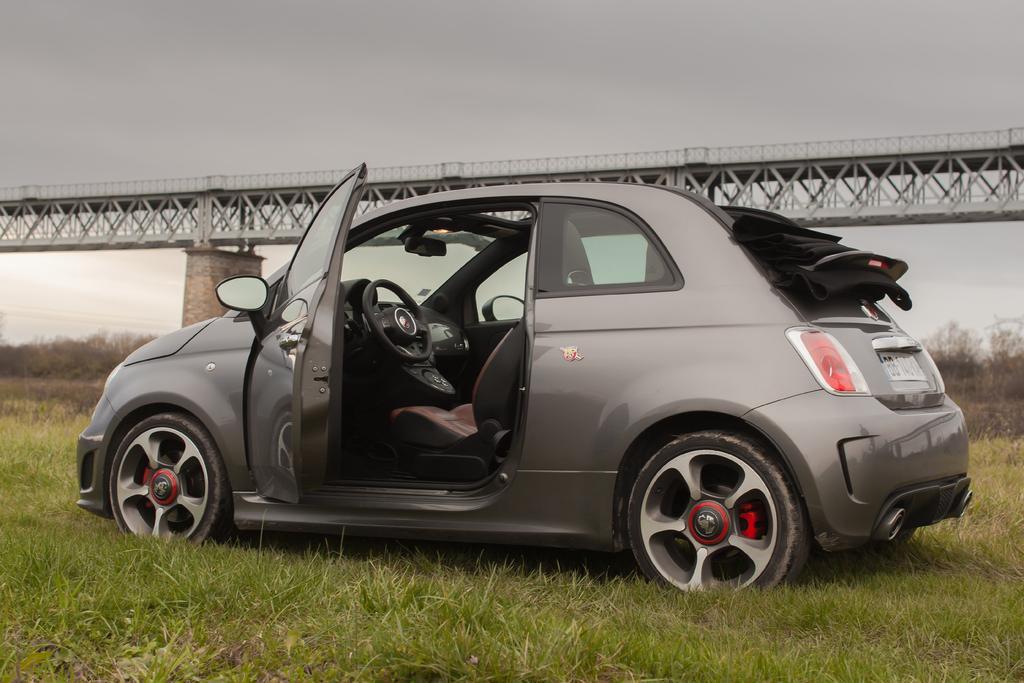Could you give a brief overview of what you see in this image? In this image we can see a motor vehicle on the grass, bridge with iron grills and sky in the background. 